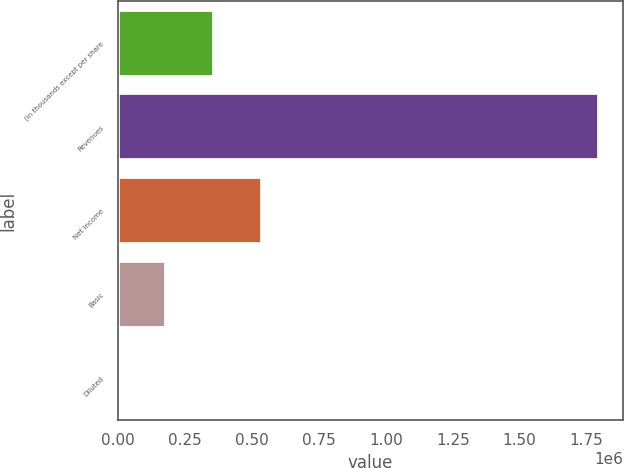Convert chart. <chart><loc_0><loc_0><loc_500><loc_500><bar_chart><fcel>(In thousands except per share<fcel>Revenues<fcel>Net income<fcel>Basic<fcel>Diluted<nl><fcel>359399<fcel>1.79699e+06<fcel>539098<fcel>179700<fcel>1.35<nl></chart> 